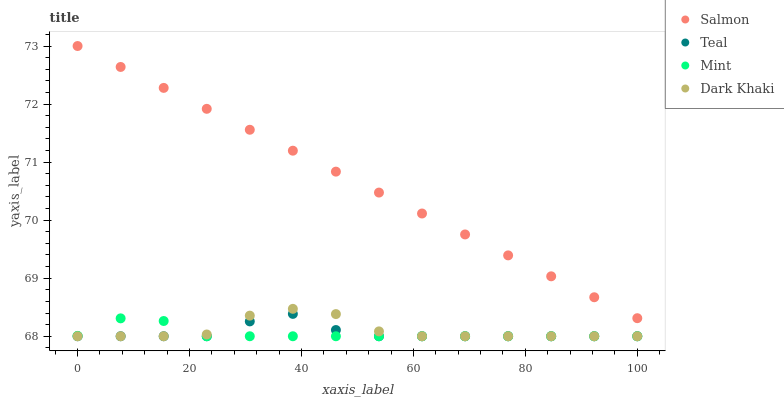Does Mint have the minimum area under the curve?
Answer yes or no. Yes. Does Salmon have the maximum area under the curve?
Answer yes or no. Yes. Does Salmon have the minimum area under the curve?
Answer yes or no. No. Does Mint have the maximum area under the curve?
Answer yes or no. No. Is Salmon the smoothest?
Answer yes or no. Yes. Is Dark Khaki the roughest?
Answer yes or no. Yes. Is Mint the smoothest?
Answer yes or no. No. Is Mint the roughest?
Answer yes or no. No. Does Dark Khaki have the lowest value?
Answer yes or no. Yes. Does Salmon have the lowest value?
Answer yes or no. No. Does Salmon have the highest value?
Answer yes or no. Yes. Does Mint have the highest value?
Answer yes or no. No. Is Dark Khaki less than Salmon?
Answer yes or no. Yes. Is Salmon greater than Teal?
Answer yes or no. Yes. Does Mint intersect Teal?
Answer yes or no. Yes. Is Mint less than Teal?
Answer yes or no. No. Is Mint greater than Teal?
Answer yes or no. No. Does Dark Khaki intersect Salmon?
Answer yes or no. No. 